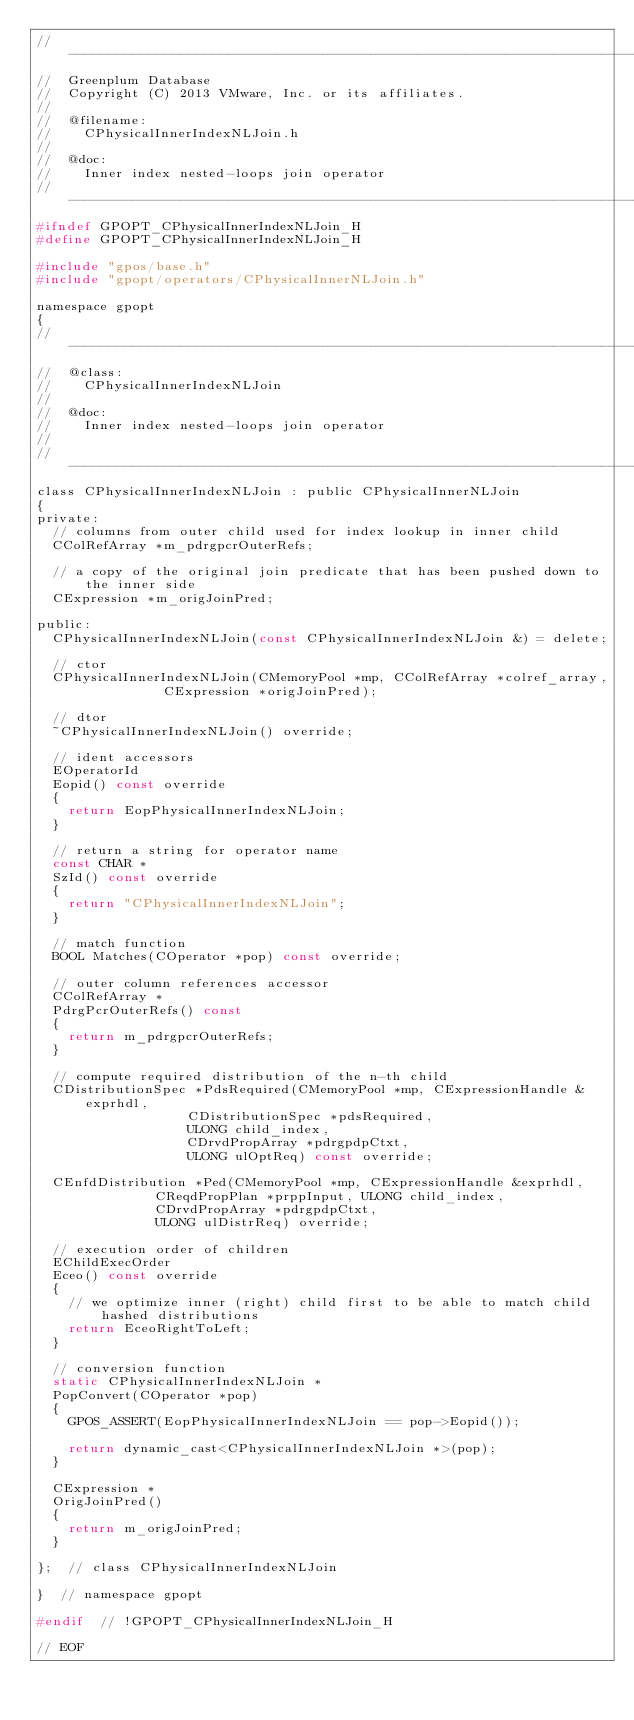<code> <loc_0><loc_0><loc_500><loc_500><_C_>//---------------------------------------------------------------------------
//	Greenplum Database
//	Copyright (C) 2013 VMware, Inc. or its affiliates.
//
//	@filename:
//		CPhysicalInnerIndexNLJoin.h
//
//	@doc:
//		Inner index nested-loops join operator
//---------------------------------------------------------------------------
#ifndef GPOPT_CPhysicalInnerIndexNLJoin_H
#define GPOPT_CPhysicalInnerIndexNLJoin_H

#include "gpos/base.h"
#include "gpopt/operators/CPhysicalInnerNLJoin.h"

namespace gpopt
{
//---------------------------------------------------------------------------
//	@class:
//		CPhysicalInnerIndexNLJoin
//
//	@doc:
//		Inner index nested-loops join operator
//
//---------------------------------------------------------------------------
class CPhysicalInnerIndexNLJoin : public CPhysicalInnerNLJoin
{
private:
	// columns from outer child used for index lookup in inner child
	CColRefArray *m_pdrgpcrOuterRefs;

	// a copy of the original join predicate that has been pushed down to the inner side
	CExpression *m_origJoinPred;

public:
	CPhysicalInnerIndexNLJoin(const CPhysicalInnerIndexNLJoin &) = delete;

	// ctor
	CPhysicalInnerIndexNLJoin(CMemoryPool *mp, CColRefArray *colref_array,
							  CExpression *origJoinPred);

	// dtor
	~CPhysicalInnerIndexNLJoin() override;

	// ident accessors
	EOperatorId
	Eopid() const override
	{
		return EopPhysicalInnerIndexNLJoin;
	}

	// return a string for operator name
	const CHAR *
	SzId() const override
	{
		return "CPhysicalInnerIndexNLJoin";
	}

	// match function
	BOOL Matches(COperator *pop) const override;

	// outer column references accessor
	CColRefArray *
	PdrgPcrOuterRefs() const
	{
		return m_pdrgpcrOuterRefs;
	}

	// compute required distribution of the n-th child
	CDistributionSpec *PdsRequired(CMemoryPool *mp, CExpressionHandle &exprhdl,
								   CDistributionSpec *pdsRequired,
								   ULONG child_index,
								   CDrvdPropArray *pdrgpdpCtxt,
								   ULONG ulOptReq) const override;

	CEnfdDistribution *Ped(CMemoryPool *mp, CExpressionHandle &exprhdl,
						   CReqdPropPlan *prppInput, ULONG child_index,
						   CDrvdPropArray *pdrgpdpCtxt,
						   ULONG ulDistrReq) override;

	// execution order of children
	EChildExecOrder
	Eceo() const override
	{
		// we optimize inner (right) child first to be able to match child hashed distributions
		return EceoRightToLeft;
	}

	// conversion function
	static CPhysicalInnerIndexNLJoin *
	PopConvert(COperator *pop)
	{
		GPOS_ASSERT(EopPhysicalInnerIndexNLJoin == pop->Eopid());

		return dynamic_cast<CPhysicalInnerIndexNLJoin *>(pop);
	}

	CExpression *
	OrigJoinPred()
	{
		return m_origJoinPred;
	}

};	// class CPhysicalInnerIndexNLJoin

}  // namespace gpopt

#endif	// !GPOPT_CPhysicalInnerIndexNLJoin_H

// EOF
</code> 